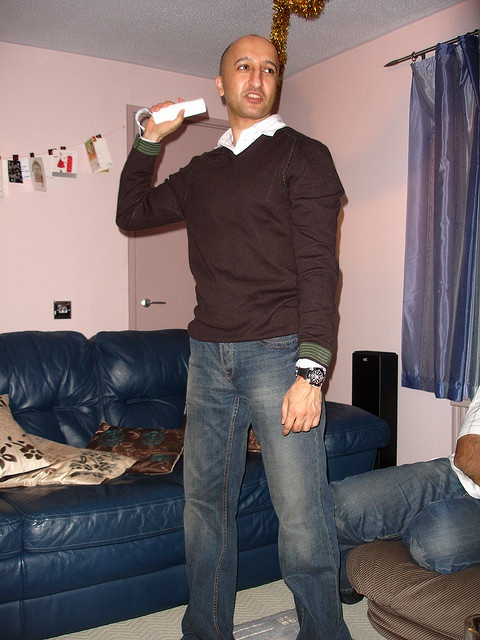Describe the objects in this image and their specific colors. I can see people in gray and black tones, couch in gray, black, navy, and blue tones, people in gray, blue, and black tones, and remote in gray, white, tan, darkgray, and salmon tones in this image. 